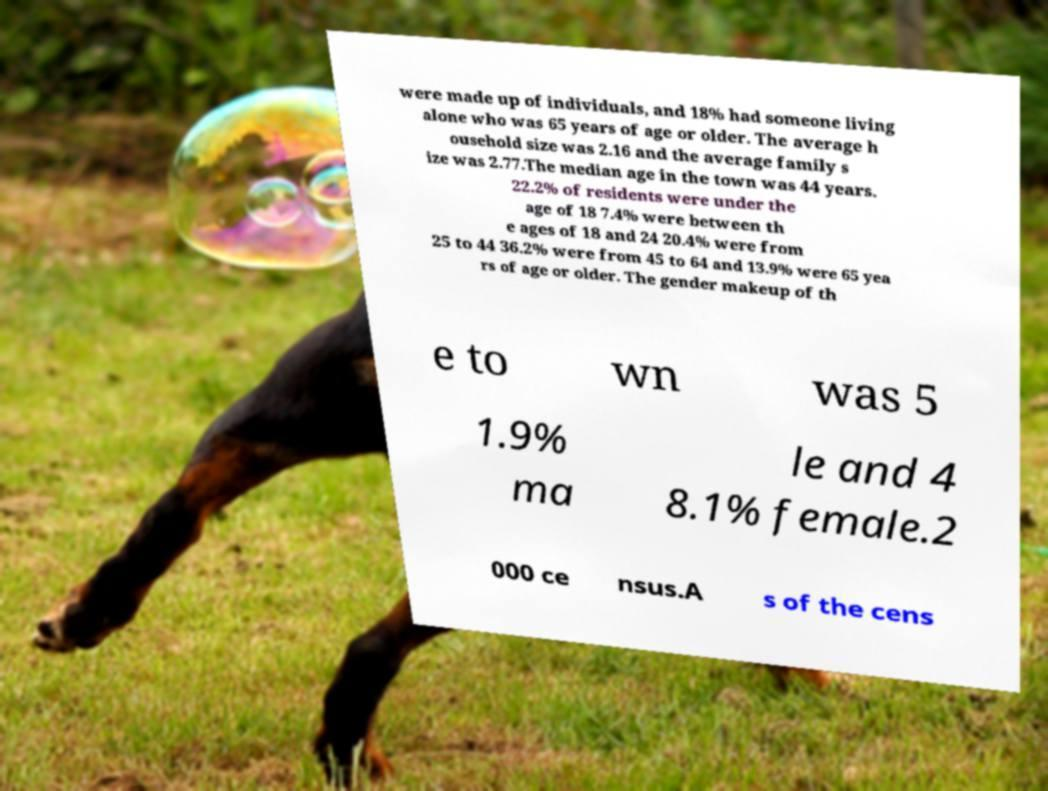Could you assist in decoding the text presented in this image and type it out clearly? were made up of individuals, and 18% had someone living alone who was 65 years of age or older. The average h ousehold size was 2.16 and the average family s ize was 2.77.The median age in the town was 44 years. 22.2% of residents were under the age of 18 7.4% were between th e ages of 18 and 24 20.4% were from 25 to 44 36.2% were from 45 to 64 and 13.9% were 65 yea rs of age or older. The gender makeup of th e to wn was 5 1.9% ma le and 4 8.1% female.2 000 ce nsus.A s of the cens 